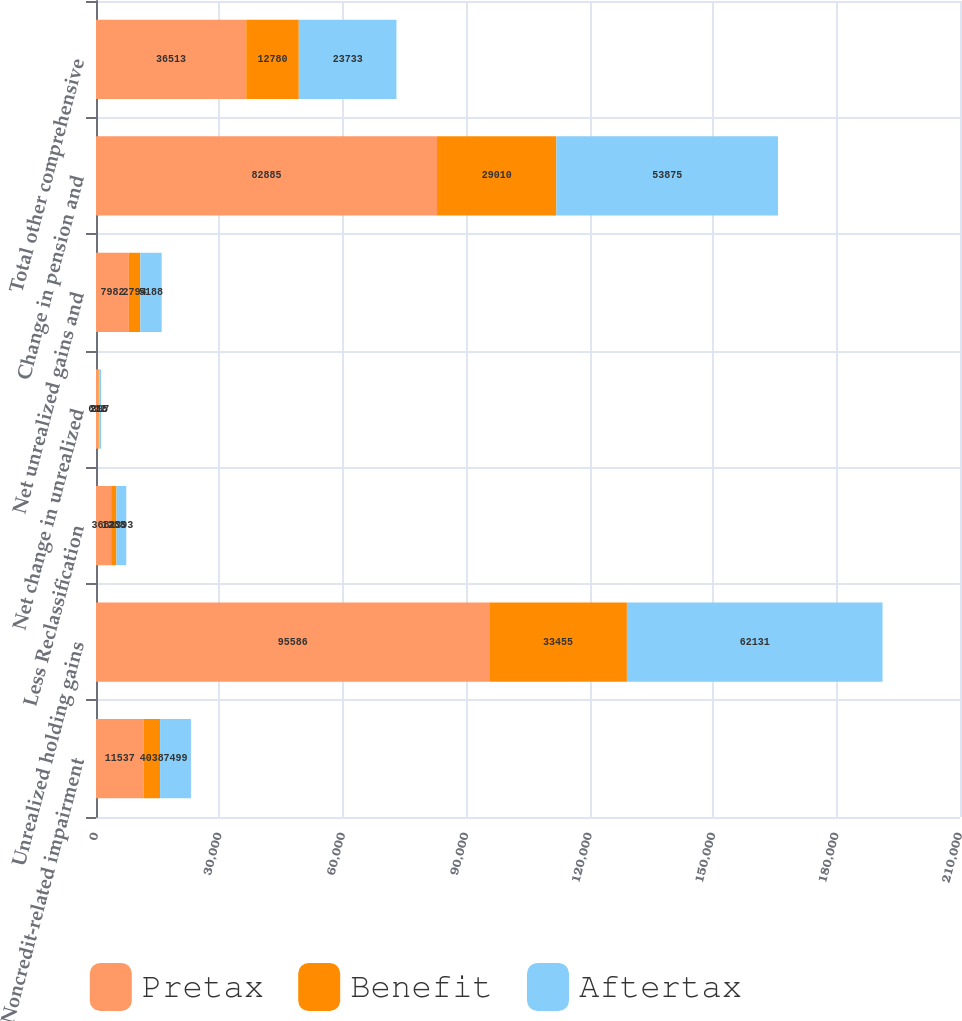Convert chart to OTSL. <chart><loc_0><loc_0><loc_500><loc_500><stacked_bar_chart><ecel><fcel>Noncredit-related impairment<fcel>Unrealized holding gains<fcel>Less Reclassification<fcel>Net change in unrealized<fcel>Net unrealized gains and<fcel>Change in pension and<fcel>Total other comprehensive<nl><fcel>Pretax<fcel>11537<fcel>95586<fcel>3681<fcel>612<fcel>7982<fcel>82885<fcel>36513<nl><fcel>Benefit<fcel>4038<fcel>33455<fcel>1288<fcel>215<fcel>2794<fcel>29010<fcel>12780<nl><fcel>Aftertax<fcel>7499<fcel>62131<fcel>2393<fcel>397<fcel>5188<fcel>53875<fcel>23733<nl></chart> 